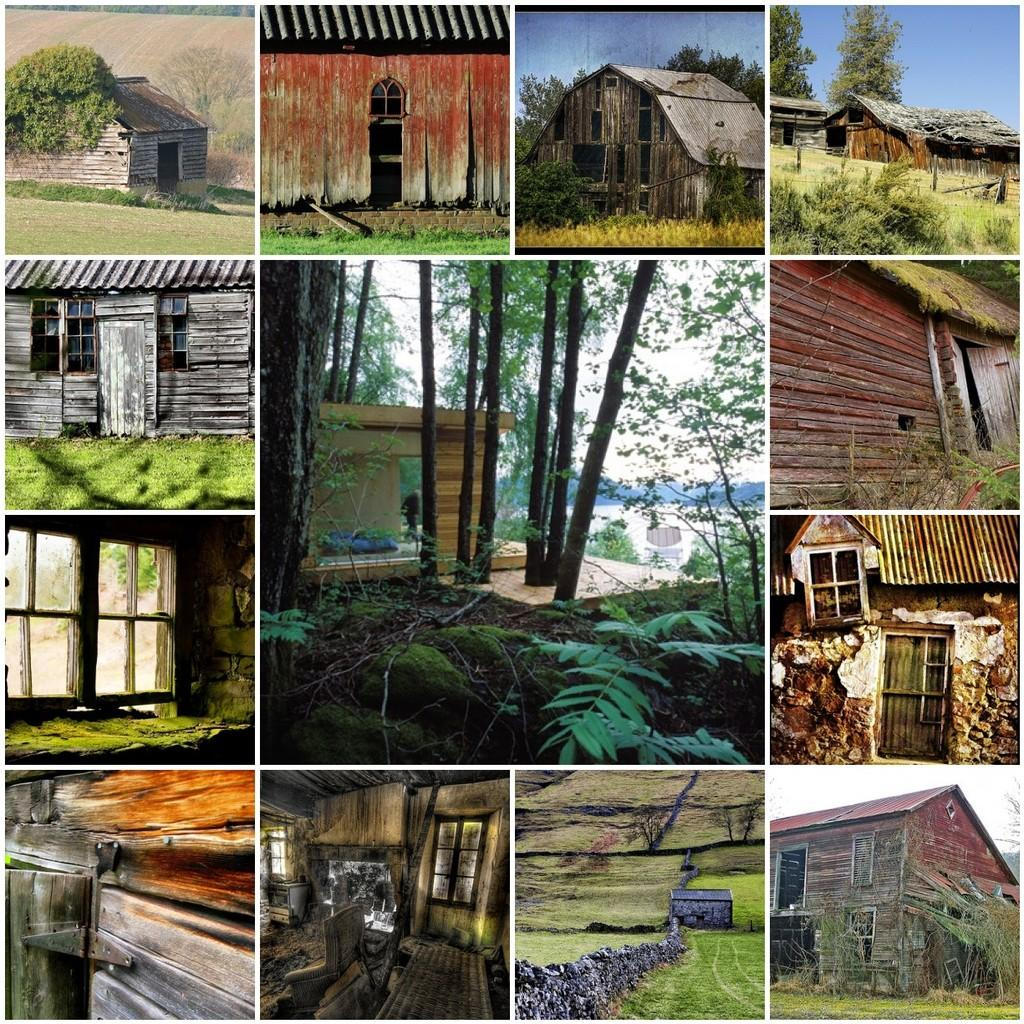What type of artwork is shown in the image? The image is a collage of different pictures. What structures can be seen in the pictures? There are shelter houses in the pictures. What architectural feature is present in the pictures? There are windows in the pictures. What type of natural environment is depicted in the pictures? There are trees in the pictures. How much toothpaste is on the road in the image? There is no toothpaste or road present in the image; it consists of a collage of pictures featuring shelter houses, windows, and trees. 